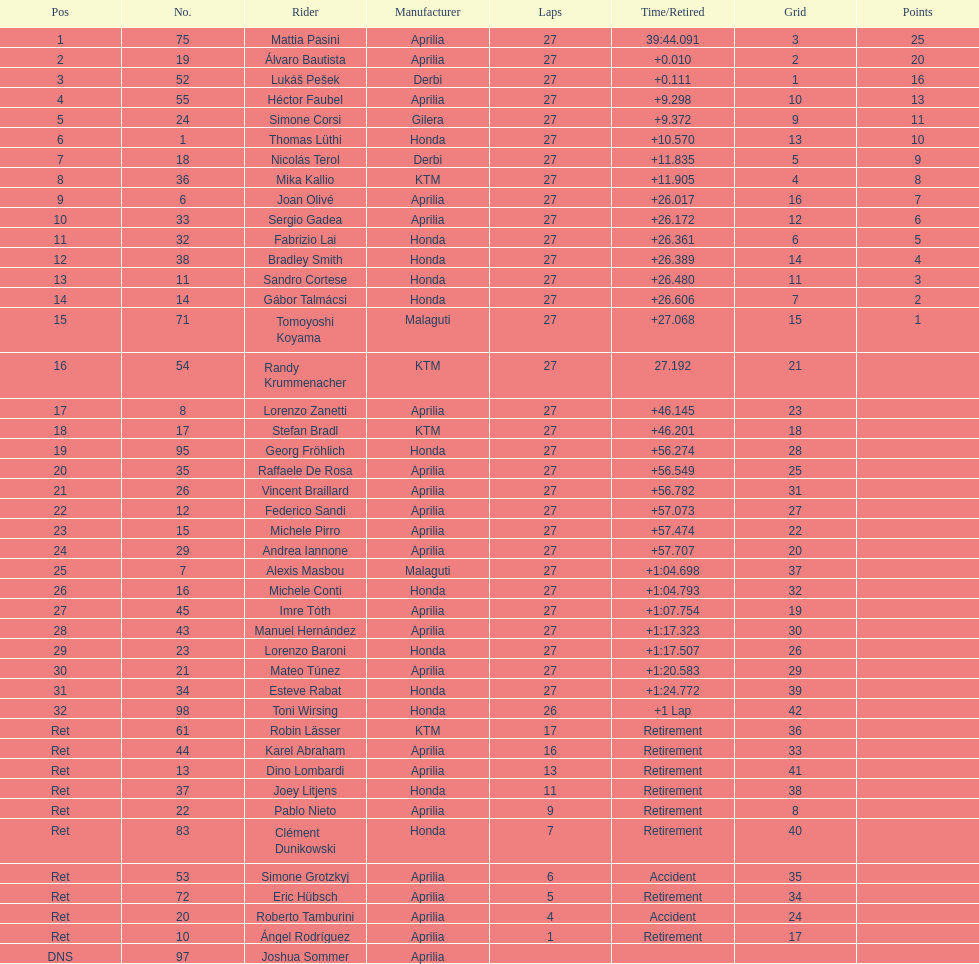How many competitors avoided using aprilia or honda motorcycles? 9. 